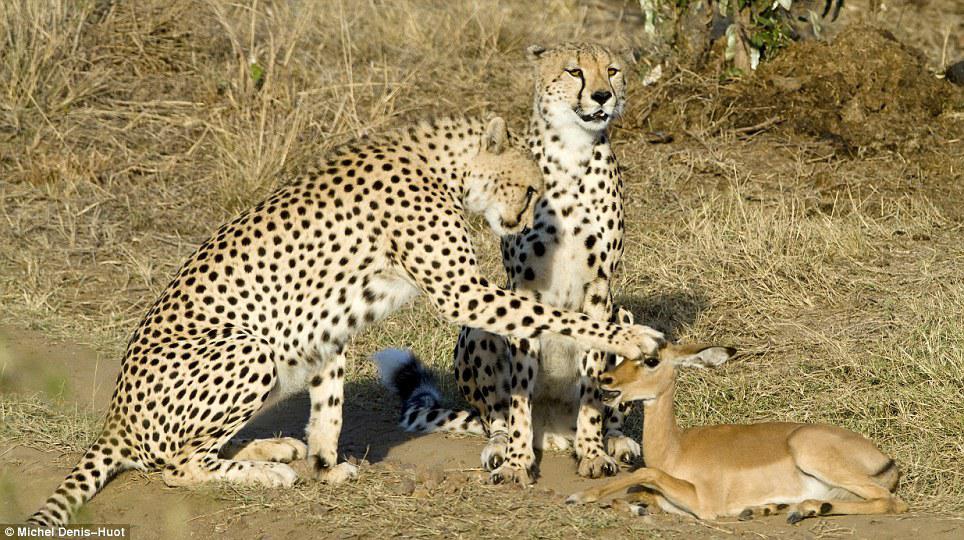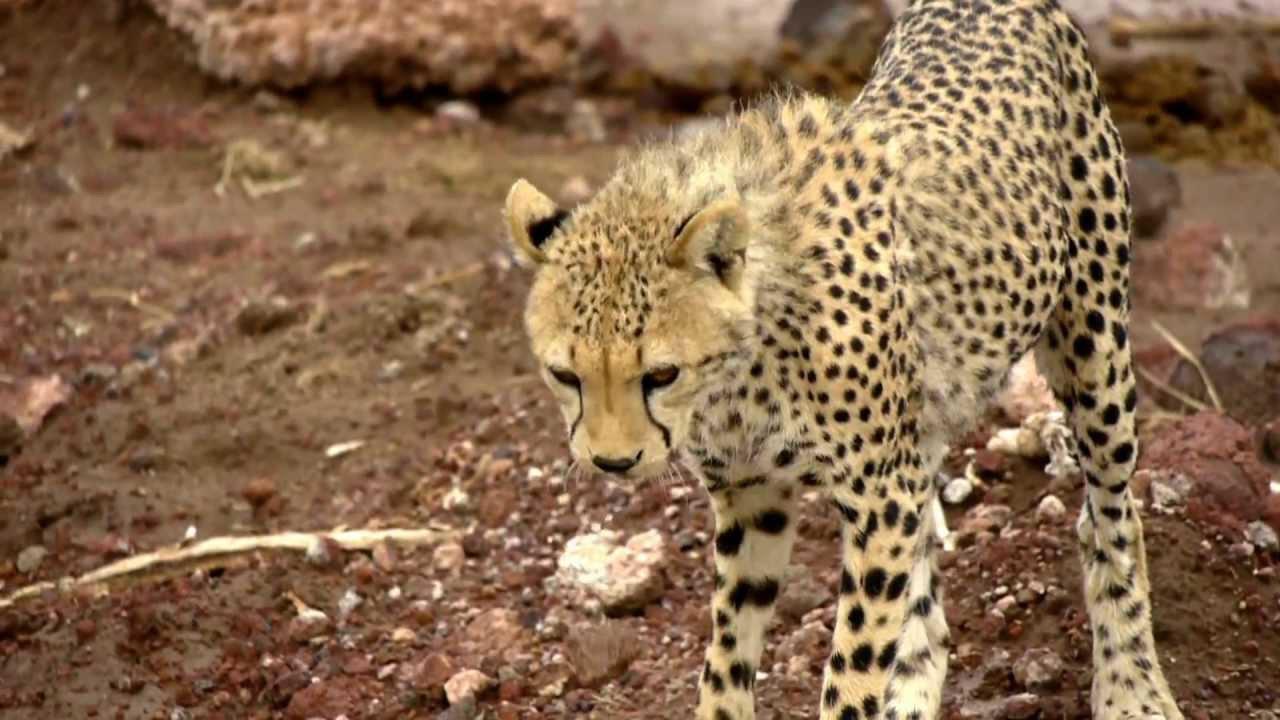The first image is the image on the left, the second image is the image on the right. For the images shown, is this caption "An image includes a wild spotted cat in a pouncing pose, with its tail up and both its front paws off the ground." true? Answer yes or no. No. The first image is the image on the left, the second image is the image on the right. Analyze the images presented: Is the assertion "There are at least four cheetahs in the right image." valid? Answer yes or no. No. 